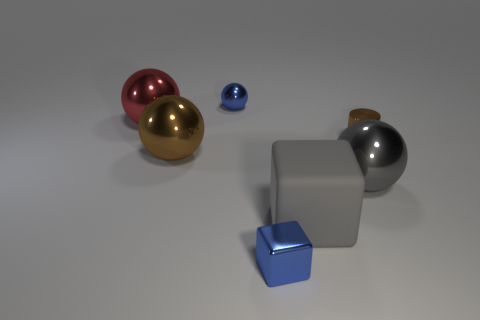Subtract all blue metallic balls. How many balls are left? 3 Subtract all brown balls. How many balls are left? 3 Subtract 1 spheres. How many spheres are left? 3 Add 1 red metallic objects. How many objects exist? 8 Subtract all spheres. How many objects are left? 3 Subtract all gray balls. Subtract all cyan cylinders. How many balls are left? 3 Subtract 0 yellow spheres. How many objects are left? 7 Subtract all red objects. Subtract all gray matte cubes. How many objects are left? 5 Add 2 small shiny blocks. How many small shiny blocks are left? 3 Add 5 large purple shiny cubes. How many large purple shiny cubes exist? 5 